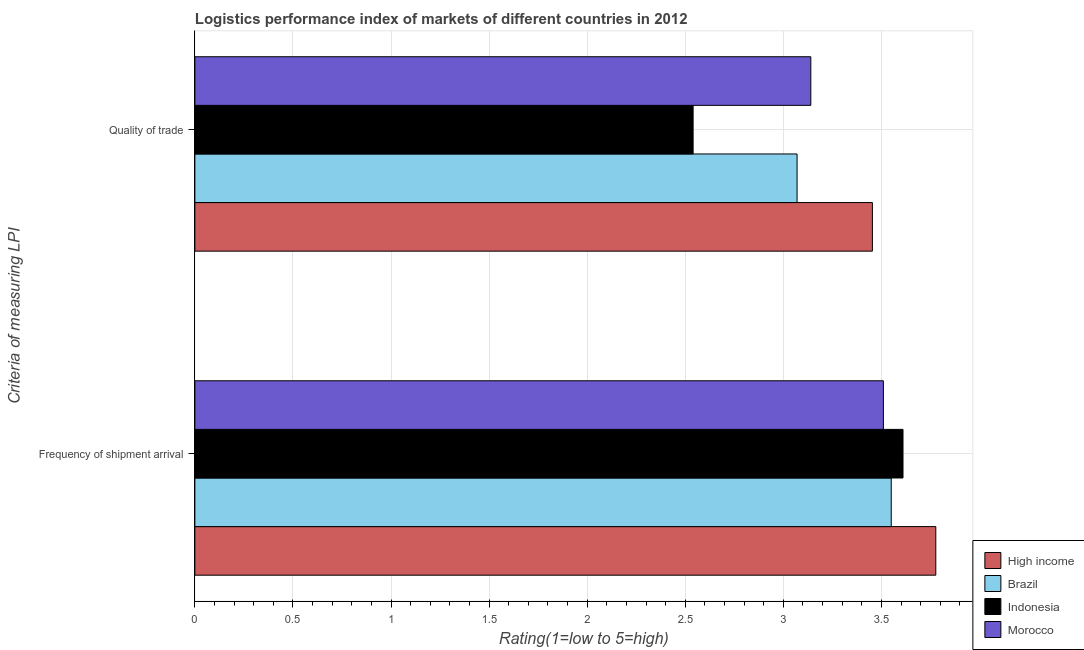How many groups of bars are there?
Provide a short and direct response. 2. Are the number of bars on each tick of the Y-axis equal?
Provide a short and direct response. Yes. How many bars are there on the 2nd tick from the top?
Provide a succinct answer. 4. How many bars are there on the 2nd tick from the bottom?
Your answer should be very brief. 4. What is the label of the 2nd group of bars from the top?
Offer a terse response. Frequency of shipment arrival. What is the lpi quality of trade in Brazil?
Keep it short and to the point. 3.07. Across all countries, what is the maximum lpi quality of trade?
Provide a succinct answer. 3.45. Across all countries, what is the minimum lpi of frequency of shipment arrival?
Ensure brevity in your answer.  3.51. What is the total lpi quality of trade in the graph?
Ensure brevity in your answer.  12.2. What is the difference between the lpi of frequency of shipment arrival in Brazil and that in High income?
Provide a succinct answer. -0.23. What is the difference between the lpi of frequency of shipment arrival in High income and the lpi quality of trade in Indonesia?
Provide a short and direct response. 1.24. What is the average lpi quality of trade per country?
Provide a short and direct response. 3.05. What is the difference between the lpi quality of trade and lpi of frequency of shipment arrival in Indonesia?
Keep it short and to the point. -1.07. In how many countries, is the lpi of frequency of shipment arrival greater than 3.1 ?
Ensure brevity in your answer.  4. What is the ratio of the lpi of frequency of shipment arrival in Morocco to that in Indonesia?
Make the answer very short. 0.97. Is the lpi of frequency of shipment arrival in Brazil less than that in Indonesia?
Ensure brevity in your answer.  Yes. In how many countries, is the lpi quality of trade greater than the average lpi quality of trade taken over all countries?
Your answer should be very brief. 3. What does the 2nd bar from the top in Frequency of shipment arrival represents?
Keep it short and to the point. Indonesia. What does the 2nd bar from the bottom in Frequency of shipment arrival represents?
Offer a terse response. Brazil. How many bars are there?
Your response must be concise. 8. Does the graph contain grids?
Keep it short and to the point. Yes. Where does the legend appear in the graph?
Ensure brevity in your answer.  Bottom right. How many legend labels are there?
Make the answer very short. 4. What is the title of the graph?
Give a very brief answer. Logistics performance index of markets of different countries in 2012. Does "Costa Rica" appear as one of the legend labels in the graph?
Ensure brevity in your answer.  No. What is the label or title of the X-axis?
Make the answer very short. Rating(1=low to 5=high). What is the label or title of the Y-axis?
Make the answer very short. Criteria of measuring LPI. What is the Rating(1=low to 5=high) of High income in Frequency of shipment arrival?
Keep it short and to the point. 3.78. What is the Rating(1=low to 5=high) of Brazil in Frequency of shipment arrival?
Your answer should be compact. 3.55. What is the Rating(1=low to 5=high) in Indonesia in Frequency of shipment arrival?
Provide a short and direct response. 3.61. What is the Rating(1=low to 5=high) in Morocco in Frequency of shipment arrival?
Your answer should be compact. 3.51. What is the Rating(1=low to 5=high) of High income in Quality of trade?
Offer a very short reply. 3.45. What is the Rating(1=low to 5=high) in Brazil in Quality of trade?
Your answer should be compact. 3.07. What is the Rating(1=low to 5=high) of Indonesia in Quality of trade?
Keep it short and to the point. 2.54. What is the Rating(1=low to 5=high) in Morocco in Quality of trade?
Provide a short and direct response. 3.14. Across all Criteria of measuring LPI, what is the maximum Rating(1=low to 5=high) of High income?
Your answer should be very brief. 3.78. Across all Criteria of measuring LPI, what is the maximum Rating(1=low to 5=high) of Brazil?
Your response must be concise. 3.55. Across all Criteria of measuring LPI, what is the maximum Rating(1=low to 5=high) in Indonesia?
Your answer should be compact. 3.61. Across all Criteria of measuring LPI, what is the maximum Rating(1=low to 5=high) of Morocco?
Give a very brief answer. 3.51. Across all Criteria of measuring LPI, what is the minimum Rating(1=low to 5=high) in High income?
Keep it short and to the point. 3.45. Across all Criteria of measuring LPI, what is the minimum Rating(1=low to 5=high) in Brazil?
Provide a short and direct response. 3.07. Across all Criteria of measuring LPI, what is the minimum Rating(1=low to 5=high) in Indonesia?
Provide a succinct answer. 2.54. Across all Criteria of measuring LPI, what is the minimum Rating(1=low to 5=high) of Morocco?
Provide a succinct answer. 3.14. What is the total Rating(1=low to 5=high) of High income in the graph?
Provide a succinct answer. 7.23. What is the total Rating(1=low to 5=high) of Brazil in the graph?
Offer a very short reply. 6.62. What is the total Rating(1=low to 5=high) in Indonesia in the graph?
Make the answer very short. 6.15. What is the total Rating(1=low to 5=high) in Morocco in the graph?
Provide a short and direct response. 6.65. What is the difference between the Rating(1=low to 5=high) in High income in Frequency of shipment arrival and that in Quality of trade?
Offer a terse response. 0.32. What is the difference between the Rating(1=low to 5=high) in Brazil in Frequency of shipment arrival and that in Quality of trade?
Your answer should be compact. 0.48. What is the difference between the Rating(1=low to 5=high) of Indonesia in Frequency of shipment arrival and that in Quality of trade?
Provide a short and direct response. 1.07. What is the difference between the Rating(1=low to 5=high) in Morocco in Frequency of shipment arrival and that in Quality of trade?
Your answer should be very brief. 0.37. What is the difference between the Rating(1=low to 5=high) in High income in Frequency of shipment arrival and the Rating(1=low to 5=high) in Brazil in Quality of trade?
Your answer should be very brief. 0.71. What is the difference between the Rating(1=low to 5=high) of High income in Frequency of shipment arrival and the Rating(1=low to 5=high) of Indonesia in Quality of trade?
Your answer should be compact. 1.24. What is the difference between the Rating(1=low to 5=high) in High income in Frequency of shipment arrival and the Rating(1=low to 5=high) in Morocco in Quality of trade?
Your answer should be compact. 0.64. What is the difference between the Rating(1=low to 5=high) of Brazil in Frequency of shipment arrival and the Rating(1=low to 5=high) of Morocco in Quality of trade?
Make the answer very short. 0.41. What is the difference between the Rating(1=low to 5=high) of Indonesia in Frequency of shipment arrival and the Rating(1=low to 5=high) of Morocco in Quality of trade?
Your answer should be very brief. 0.47. What is the average Rating(1=low to 5=high) of High income per Criteria of measuring LPI?
Your answer should be compact. 3.62. What is the average Rating(1=low to 5=high) in Brazil per Criteria of measuring LPI?
Your response must be concise. 3.31. What is the average Rating(1=low to 5=high) of Indonesia per Criteria of measuring LPI?
Give a very brief answer. 3.08. What is the average Rating(1=low to 5=high) of Morocco per Criteria of measuring LPI?
Provide a succinct answer. 3.33. What is the difference between the Rating(1=low to 5=high) in High income and Rating(1=low to 5=high) in Brazil in Frequency of shipment arrival?
Keep it short and to the point. 0.23. What is the difference between the Rating(1=low to 5=high) in High income and Rating(1=low to 5=high) in Indonesia in Frequency of shipment arrival?
Ensure brevity in your answer.  0.17. What is the difference between the Rating(1=low to 5=high) of High income and Rating(1=low to 5=high) of Morocco in Frequency of shipment arrival?
Provide a short and direct response. 0.27. What is the difference between the Rating(1=low to 5=high) in Brazil and Rating(1=low to 5=high) in Indonesia in Frequency of shipment arrival?
Give a very brief answer. -0.06. What is the difference between the Rating(1=low to 5=high) of High income and Rating(1=low to 5=high) of Brazil in Quality of trade?
Keep it short and to the point. 0.38. What is the difference between the Rating(1=low to 5=high) of High income and Rating(1=low to 5=high) of Indonesia in Quality of trade?
Offer a terse response. 0.91. What is the difference between the Rating(1=low to 5=high) in High income and Rating(1=low to 5=high) in Morocco in Quality of trade?
Give a very brief answer. 0.31. What is the difference between the Rating(1=low to 5=high) of Brazil and Rating(1=low to 5=high) of Indonesia in Quality of trade?
Give a very brief answer. 0.53. What is the difference between the Rating(1=low to 5=high) of Brazil and Rating(1=low to 5=high) of Morocco in Quality of trade?
Provide a short and direct response. -0.07. What is the difference between the Rating(1=low to 5=high) of Indonesia and Rating(1=low to 5=high) of Morocco in Quality of trade?
Provide a succinct answer. -0.6. What is the ratio of the Rating(1=low to 5=high) of High income in Frequency of shipment arrival to that in Quality of trade?
Your response must be concise. 1.09. What is the ratio of the Rating(1=low to 5=high) in Brazil in Frequency of shipment arrival to that in Quality of trade?
Give a very brief answer. 1.16. What is the ratio of the Rating(1=low to 5=high) in Indonesia in Frequency of shipment arrival to that in Quality of trade?
Your answer should be very brief. 1.42. What is the ratio of the Rating(1=low to 5=high) of Morocco in Frequency of shipment arrival to that in Quality of trade?
Offer a very short reply. 1.12. What is the difference between the highest and the second highest Rating(1=low to 5=high) in High income?
Give a very brief answer. 0.32. What is the difference between the highest and the second highest Rating(1=low to 5=high) in Brazil?
Offer a terse response. 0.48. What is the difference between the highest and the second highest Rating(1=low to 5=high) in Indonesia?
Give a very brief answer. 1.07. What is the difference between the highest and the second highest Rating(1=low to 5=high) of Morocco?
Provide a succinct answer. 0.37. What is the difference between the highest and the lowest Rating(1=low to 5=high) in High income?
Make the answer very short. 0.32. What is the difference between the highest and the lowest Rating(1=low to 5=high) of Brazil?
Provide a short and direct response. 0.48. What is the difference between the highest and the lowest Rating(1=low to 5=high) in Indonesia?
Make the answer very short. 1.07. What is the difference between the highest and the lowest Rating(1=low to 5=high) in Morocco?
Your answer should be compact. 0.37. 